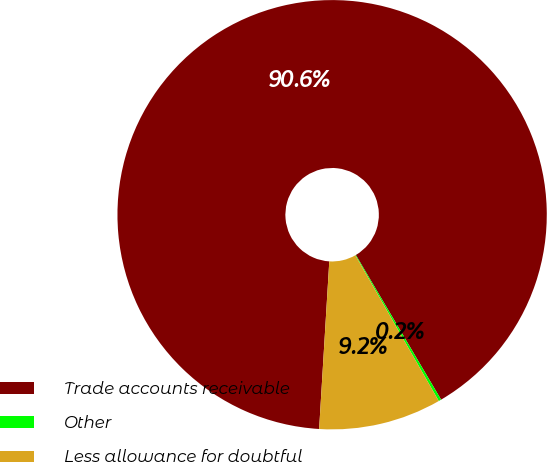<chart> <loc_0><loc_0><loc_500><loc_500><pie_chart><fcel>Trade accounts receivable<fcel>Other<fcel>Less allowance for doubtful<nl><fcel>90.56%<fcel>0.2%<fcel>9.24%<nl></chart> 